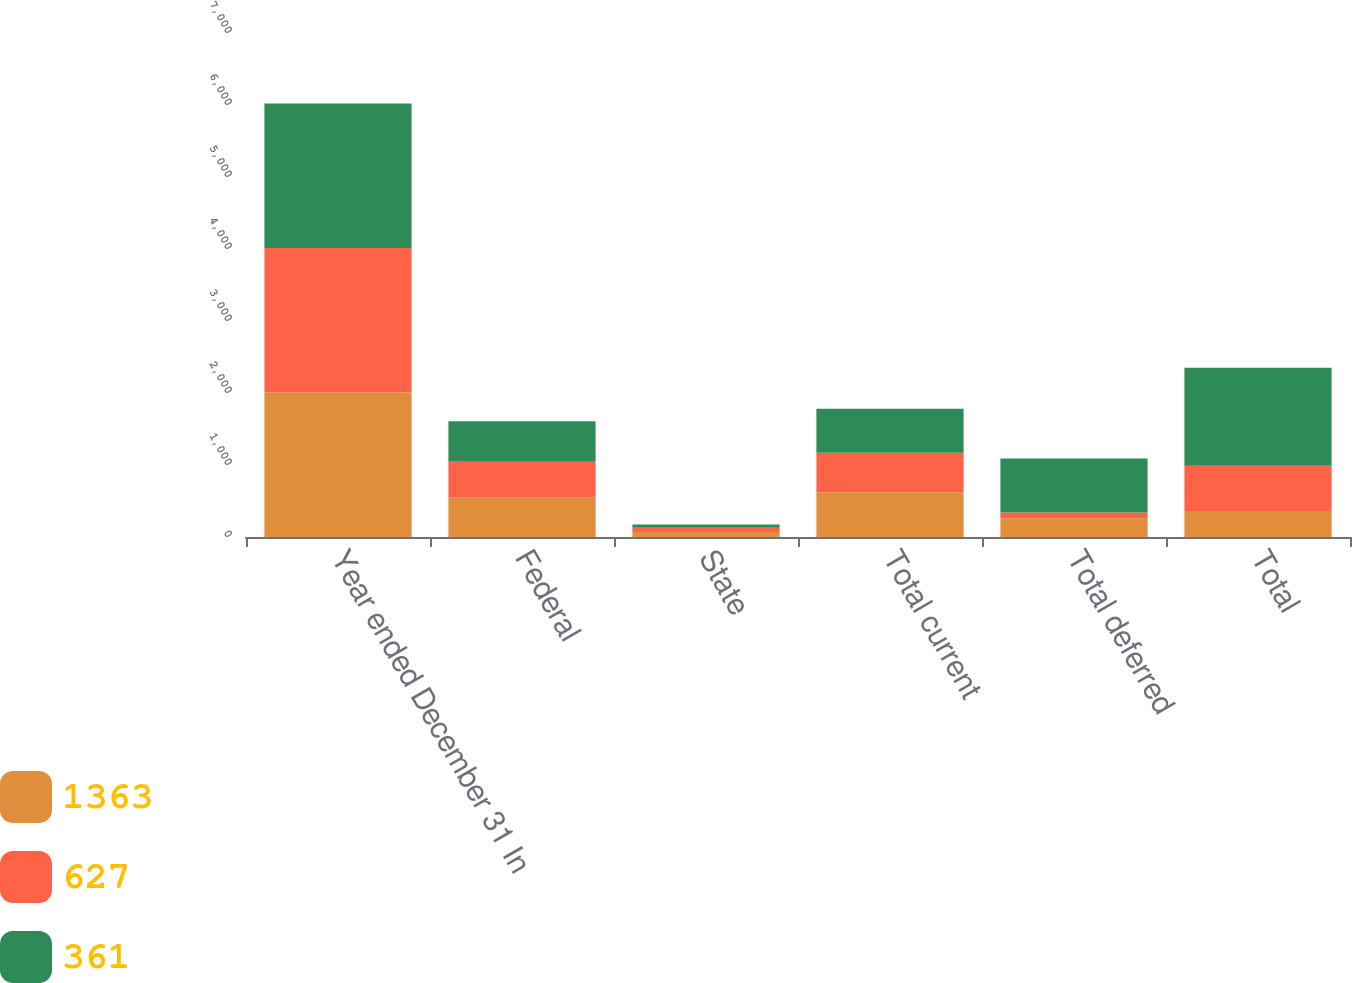<chart> <loc_0><loc_0><loc_500><loc_500><stacked_bar_chart><ecel><fcel>Year ended December 31 In<fcel>Federal<fcel>State<fcel>Total current<fcel>Total deferred<fcel>Total<nl><fcel>1363<fcel>2008<fcel>553<fcel>69<fcel>622<fcel>261<fcel>361<nl><fcel>627<fcel>2007<fcel>491<fcel>58<fcel>549<fcel>78<fcel>627<nl><fcel>361<fcel>2006<fcel>565<fcel>46<fcel>611<fcel>752<fcel>1363<nl></chart> 